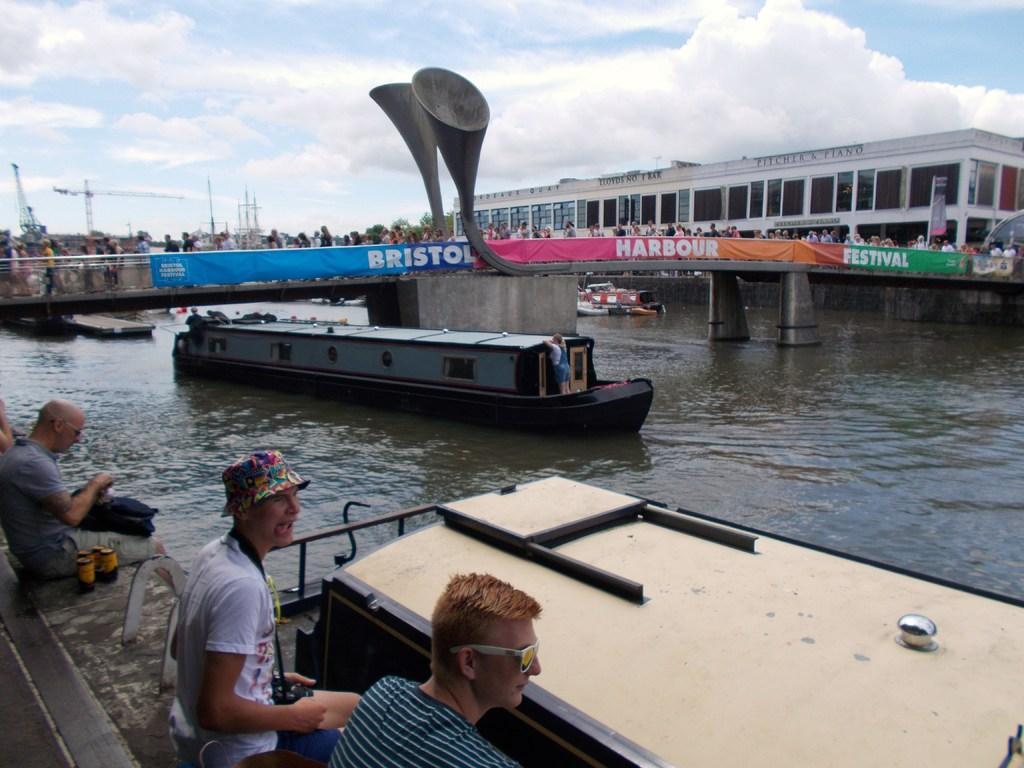In one or two sentences, can you explain what this image depicts? In this image there is the sky, there are clouds in the sky, there is a building towards the right of the image, there is a bridge, there are persons on the bridge, there are banners attached to the bridge, there are persons sitting, there is are objects on the ground, there is an object truncated towards the right of the image. 